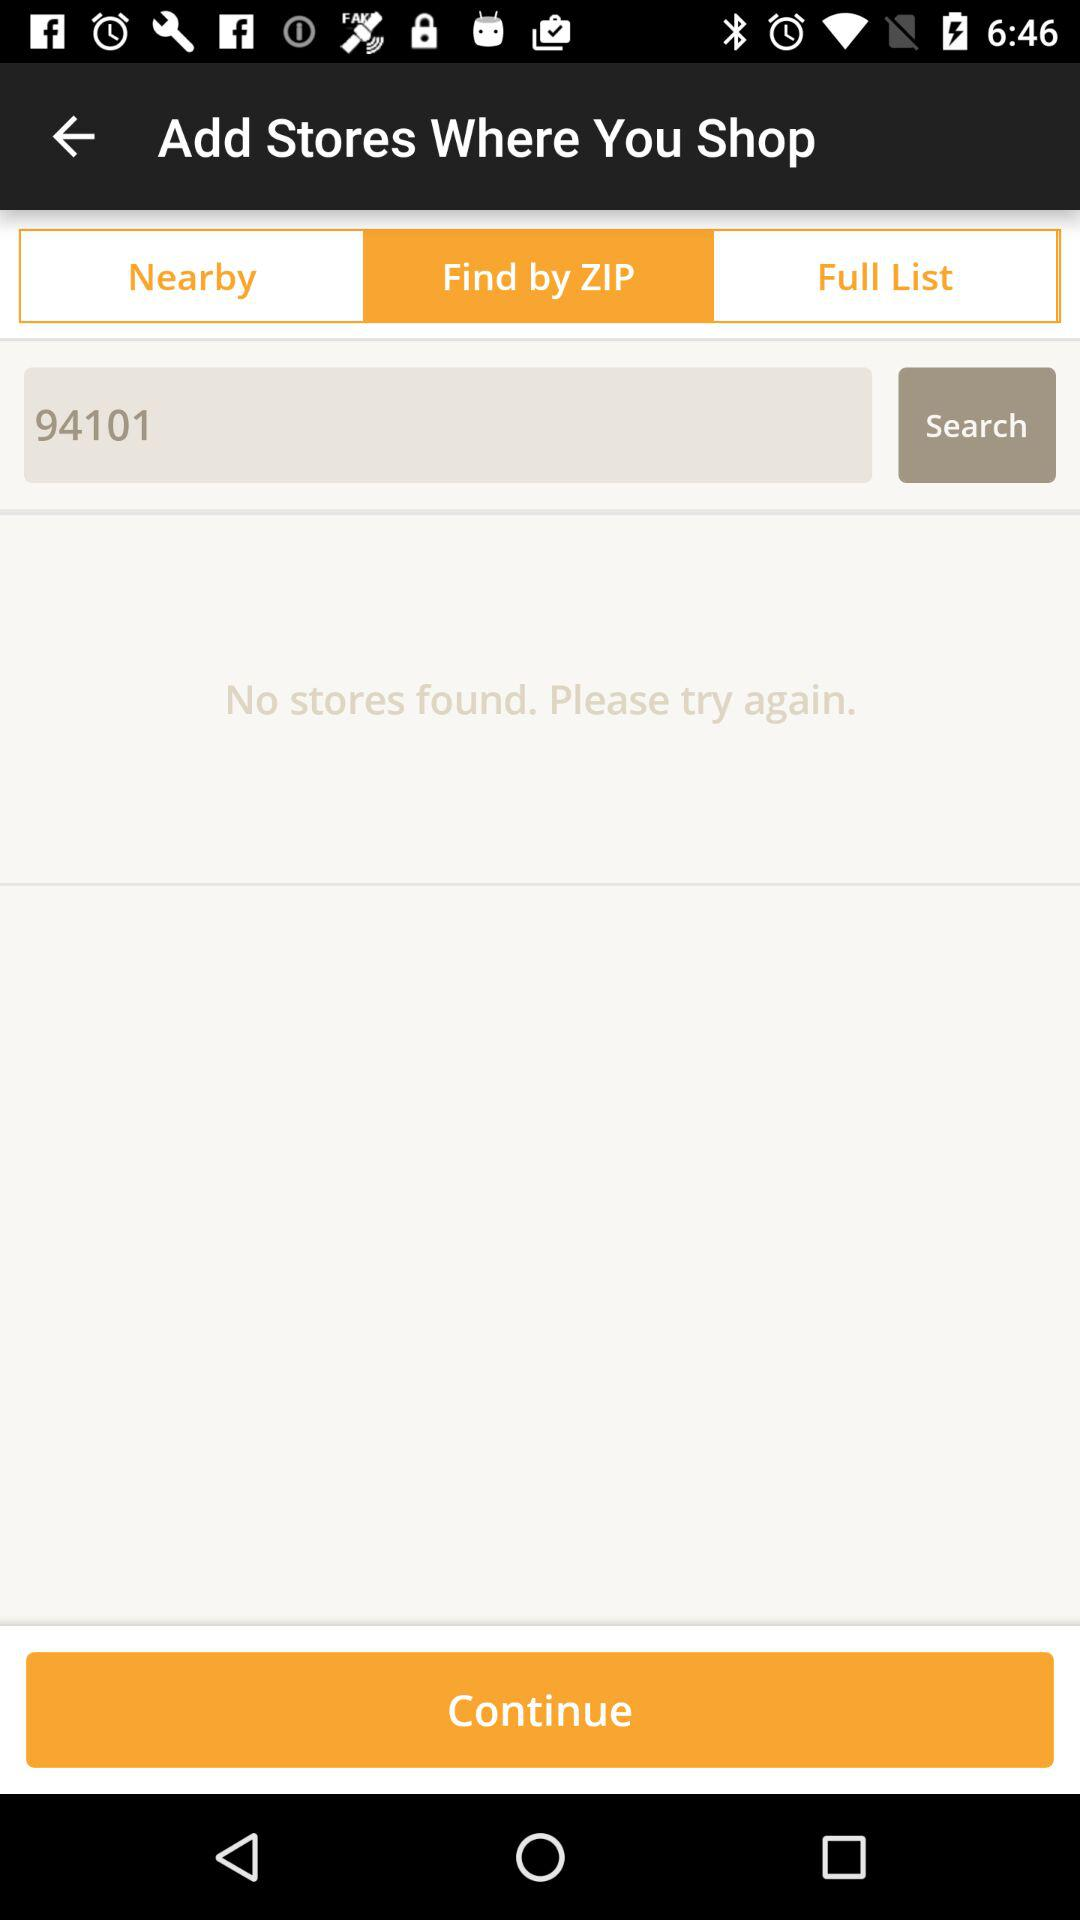What is the selected tab to search stores? The selected tab is "Find by ZIP". 